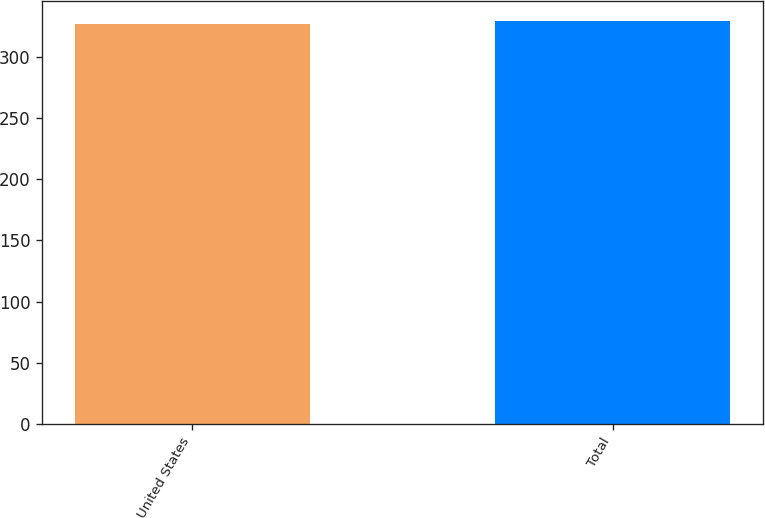<chart> <loc_0><loc_0><loc_500><loc_500><bar_chart><fcel>United States<fcel>Total<nl><fcel>327<fcel>330<nl></chart> 